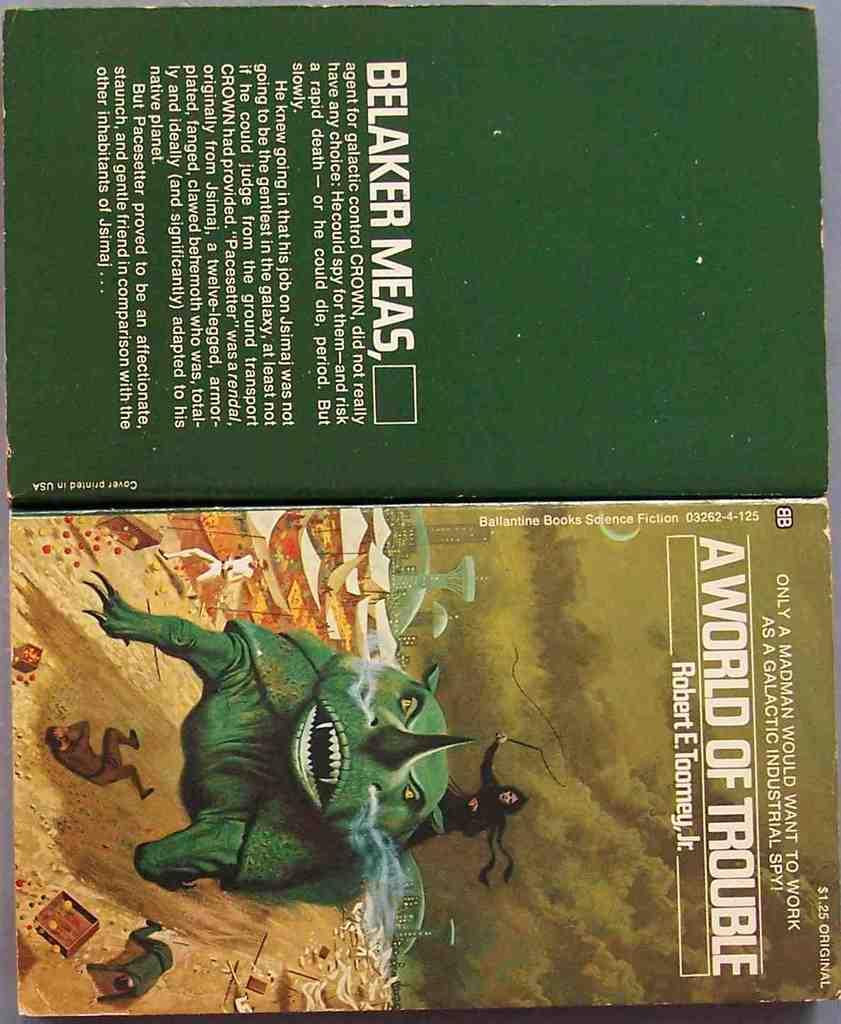<image>
Share a concise interpretation of the image provided. An old sci-fi book by Robert E. Toomey, Jr. was originally sold for $1.25. 